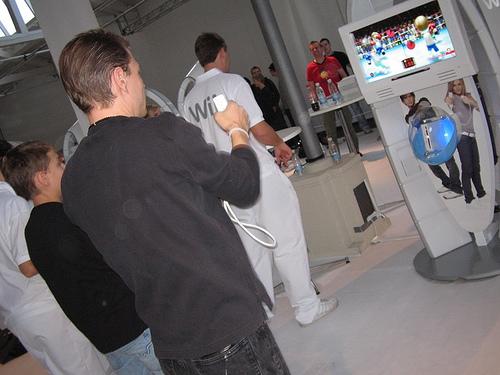What is the man cooking?
Write a very short answer. Nothing. Are these people home?
Keep it brief. No. Is this a convention?
Keep it brief. Yes. What system are they playing this game on?
Write a very short answer. Wii. 